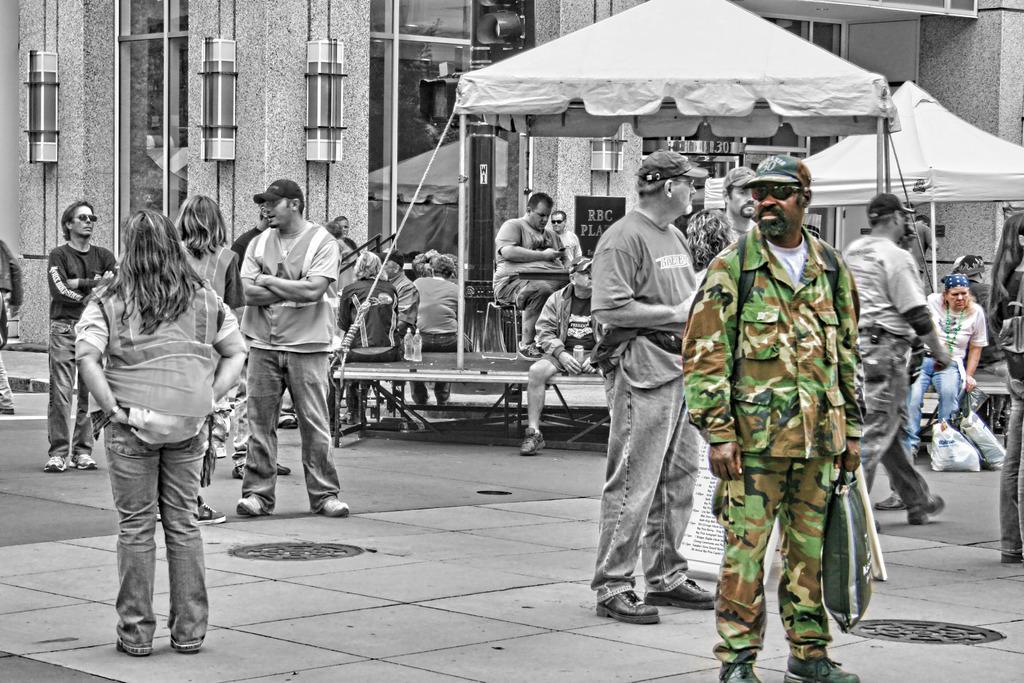In one or two sentences, can you explain what this image depicts? This is an edited image. In this image we can see a group of people standing on the ground. We can also see some people under the tents, the ropes, some bottles on the stand and a building. 